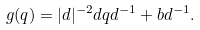<formula> <loc_0><loc_0><loc_500><loc_500>g ( q ) = | d | ^ { - 2 } d q d ^ { - 1 } + b d ^ { - 1 } .</formula> 